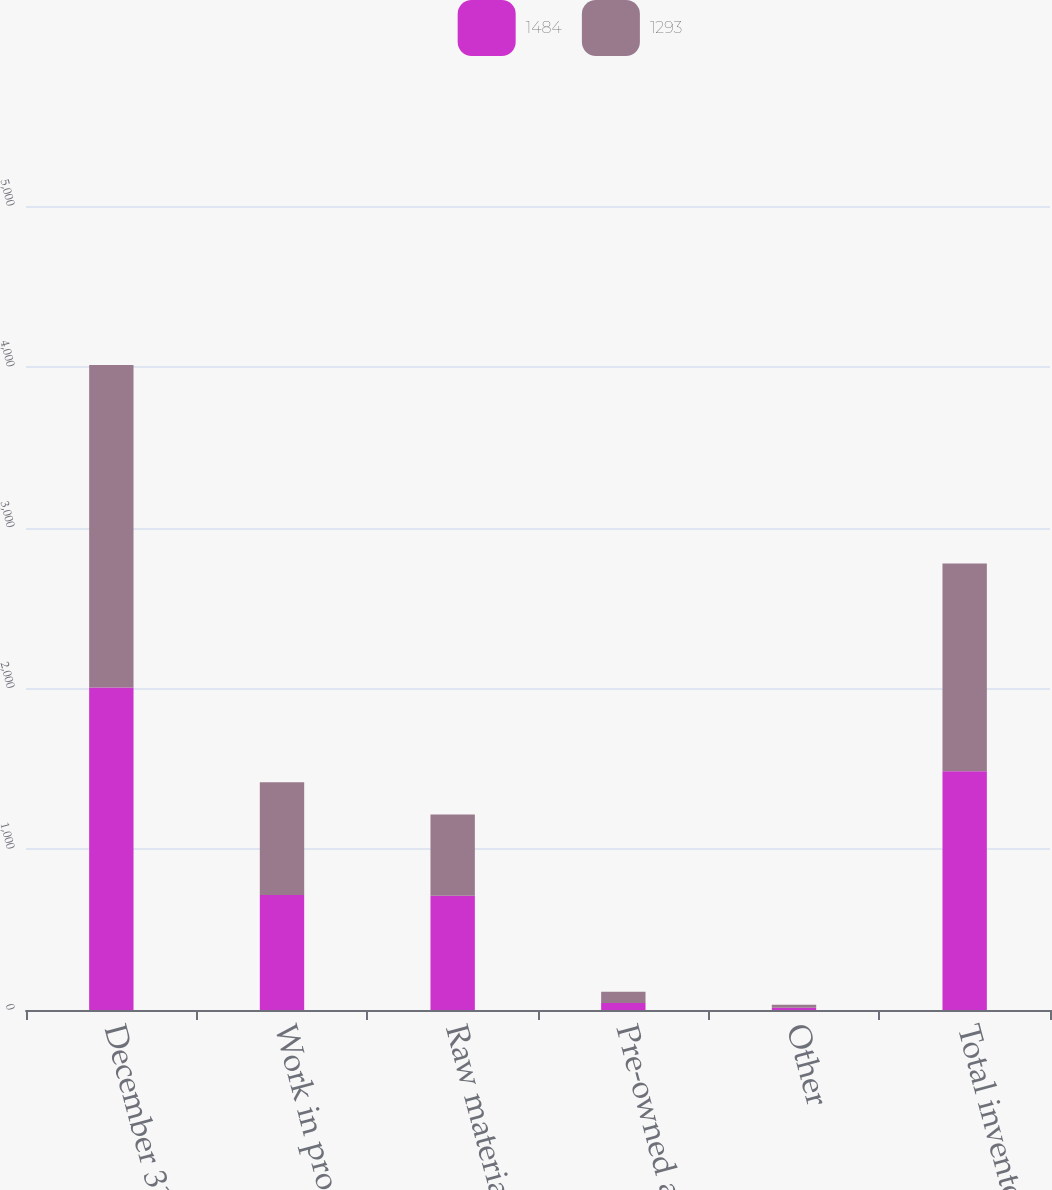<chart> <loc_0><loc_0><loc_500><loc_500><stacked_bar_chart><ecel><fcel>December 31<fcel>Work in process<fcel>Raw materials<fcel>Pre-owned aircraft<fcel>Other<fcel>Total inventories<nl><fcel>1484<fcel>2006<fcel>715<fcel>711<fcel>44<fcel>14<fcel>1484<nl><fcel>1293<fcel>2005<fcel>701<fcel>505<fcel>69<fcel>18<fcel>1293<nl></chart> 